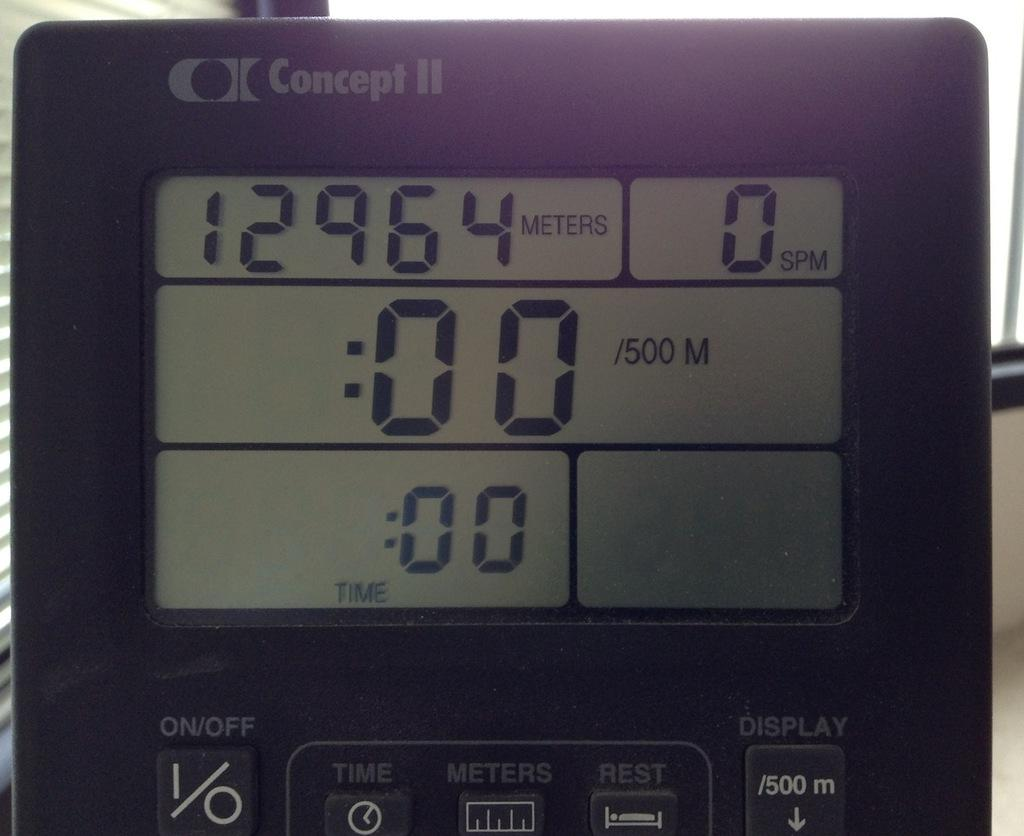<image>
Create a compact narrative representing the image presented. A digital Concept II display clock with 12,964 meters displayed on it. 